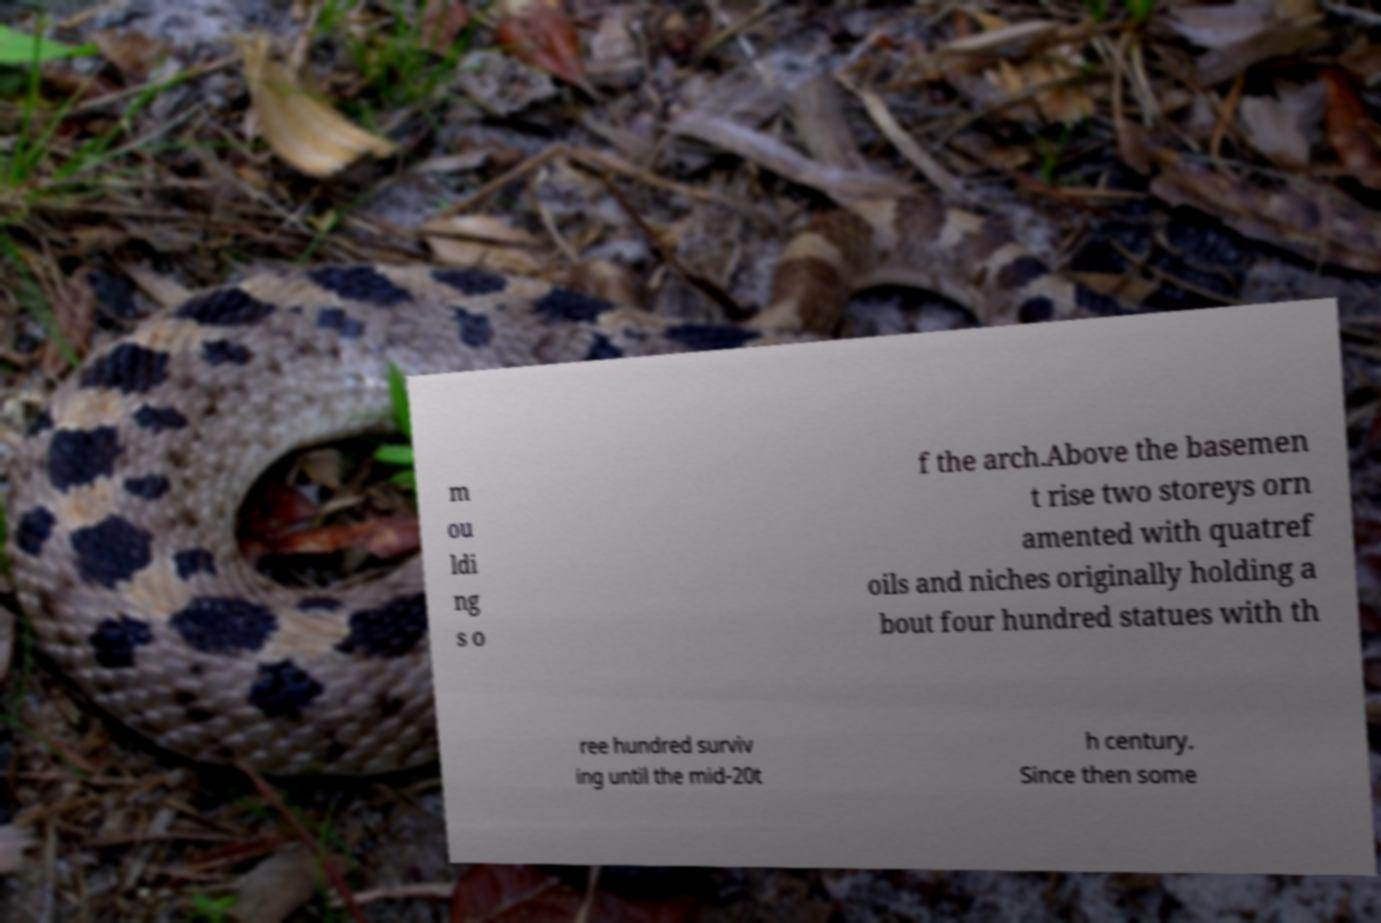Could you extract and type out the text from this image? m ou ldi ng s o f the arch.Above the basemen t rise two storeys orn amented with quatref oils and niches originally holding a bout four hundred statues with th ree hundred surviv ing until the mid-20t h century. Since then some 